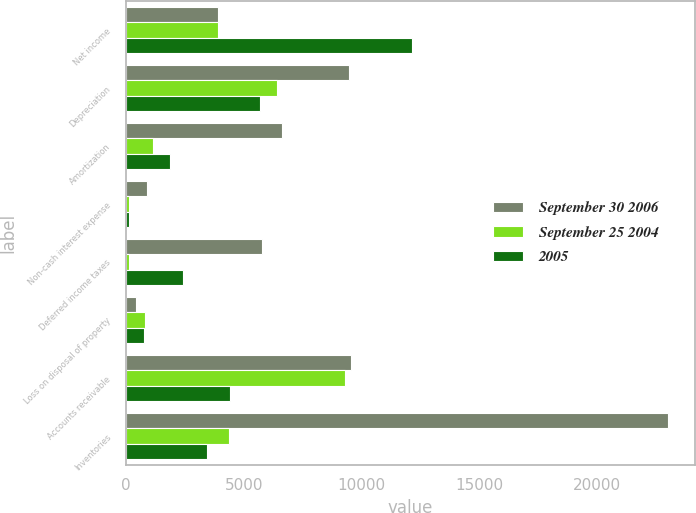<chart> <loc_0><loc_0><loc_500><loc_500><stacked_bar_chart><ecel><fcel>Net income<fcel>Depreciation<fcel>Amortization<fcel>Non-cash interest expense<fcel>Deferred income taxes<fcel>Loss on disposal of property<fcel>Accounts receivable<fcel>Inventories<nl><fcel>September 30 2006<fcel>3904.5<fcel>9492<fcel>6641<fcel>899<fcel>5797<fcel>420<fcel>9545<fcel>23023<nl><fcel>September 25 2004<fcel>3904.5<fcel>6421<fcel>1153<fcel>133<fcel>135<fcel>805<fcel>9310<fcel>4381<nl><fcel>2005<fcel>12164<fcel>5712<fcel>1877<fcel>123<fcel>2436<fcel>744<fcel>4435<fcel>3428<nl></chart> 